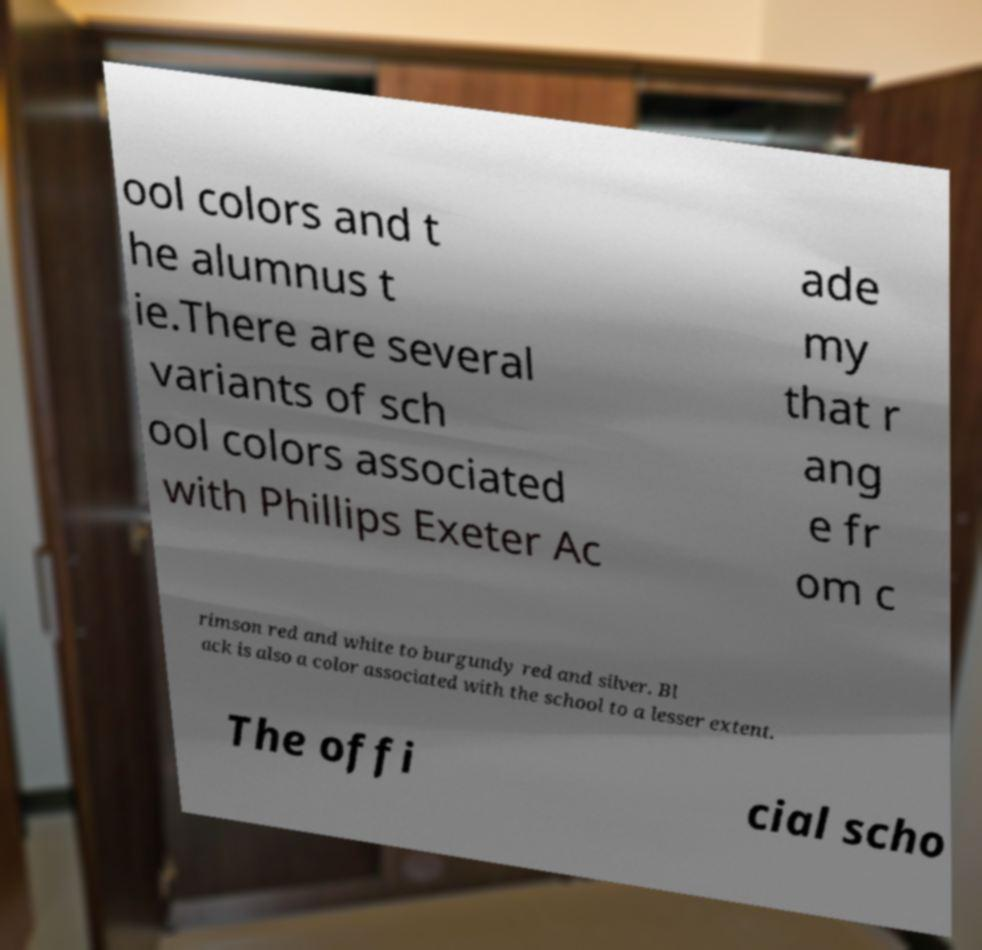Can you read and provide the text displayed in the image?This photo seems to have some interesting text. Can you extract and type it out for me? ool colors and t he alumnus t ie.There are several variants of sch ool colors associated with Phillips Exeter Ac ade my that r ang e fr om c rimson red and white to burgundy red and silver. Bl ack is also a color associated with the school to a lesser extent. The offi cial scho 